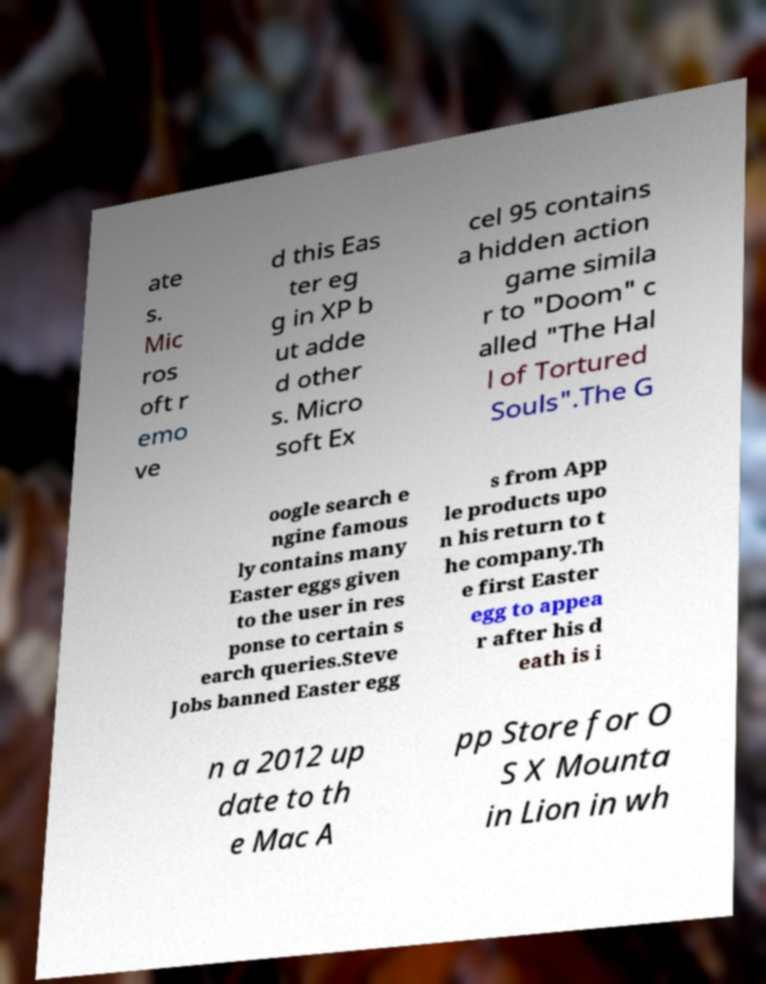Can you read and provide the text displayed in the image?This photo seems to have some interesting text. Can you extract and type it out for me? ate s. Mic ros oft r emo ve d this Eas ter eg g in XP b ut adde d other s. Micro soft Ex cel 95 contains a hidden action game simila r to "Doom" c alled "The Hal l of Tortured Souls".The G oogle search e ngine famous ly contains many Easter eggs given to the user in res ponse to certain s earch queries.Steve Jobs banned Easter egg s from App le products upo n his return to t he company.Th e first Easter egg to appea r after his d eath is i n a 2012 up date to th e Mac A pp Store for O S X Mounta in Lion in wh 